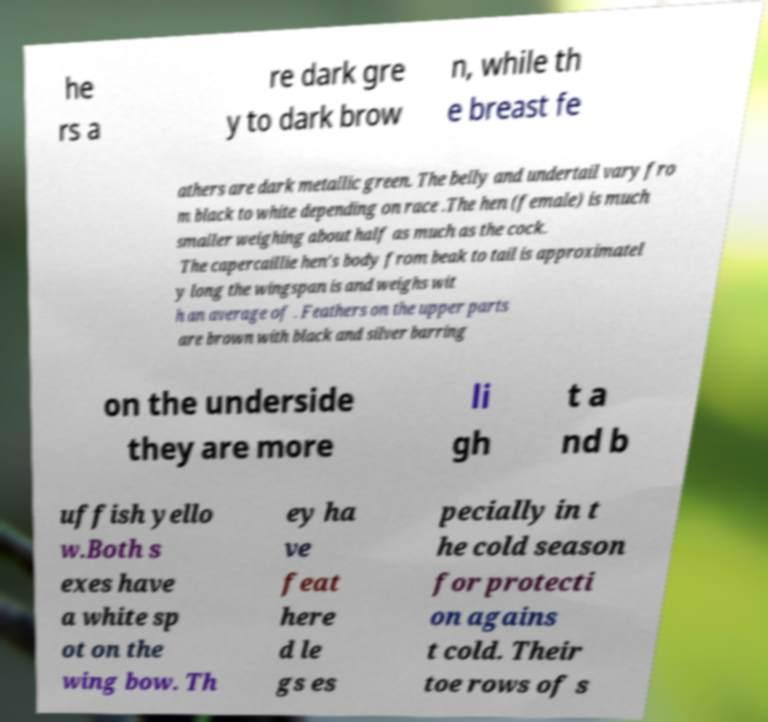Could you assist in decoding the text presented in this image and type it out clearly? he rs a re dark gre y to dark brow n, while th e breast fe athers are dark metallic green. The belly and undertail vary fro m black to white depending on race .The hen (female) is much smaller weighing about half as much as the cock. The capercaillie hen's body from beak to tail is approximatel y long the wingspan is and weighs wit h an average of . Feathers on the upper parts are brown with black and silver barring on the underside they are more li gh t a nd b uffish yello w.Both s exes have a white sp ot on the wing bow. Th ey ha ve feat here d le gs es pecially in t he cold season for protecti on agains t cold. Their toe rows of s 